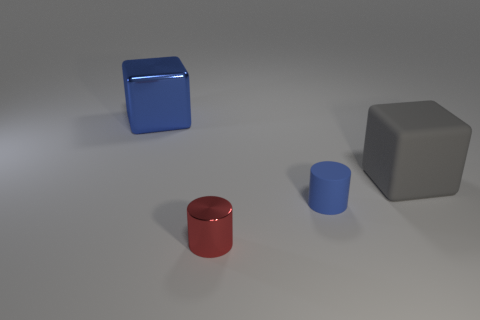Are there any large blue objects on the left side of the red metal thing?
Ensure brevity in your answer.  Yes. There is a metal cylinder; is its size the same as the cube that is to the left of the tiny metallic thing?
Offer a terse response. No. The cylinder that is in front of the tiny cylinder right of the metallic cylinder is what color?
Make the answer very short. Red. Do the red thing and the blue matte cylinder have the same size?
Provide a succinct answer. Yes. What is the color of the thing that is both in front of the large blue metal cube and to the left of the blue rubber thing?
Offer a terse response. Red. What is the size of the matte block?
Ensure brevity in your answer.  Large. Does the small cylinder that is behind the tiny red metal cylinder have the same color as the shiny cube?
Keep it short and to the point. Yes. Are there more things that are in front of the big blue object than blue metallic things that are on the right side of the tiny rubber thing?
Your response must be concise. Yes. Is the number of purple rubber blocks greater than the number of rubber blocks?
Ensure brevity in your answer.  No. How big is the object that is both on the left side of the gray cube and to the right of the small red cylinder?
Ensure brevity in your answer.  Small. 